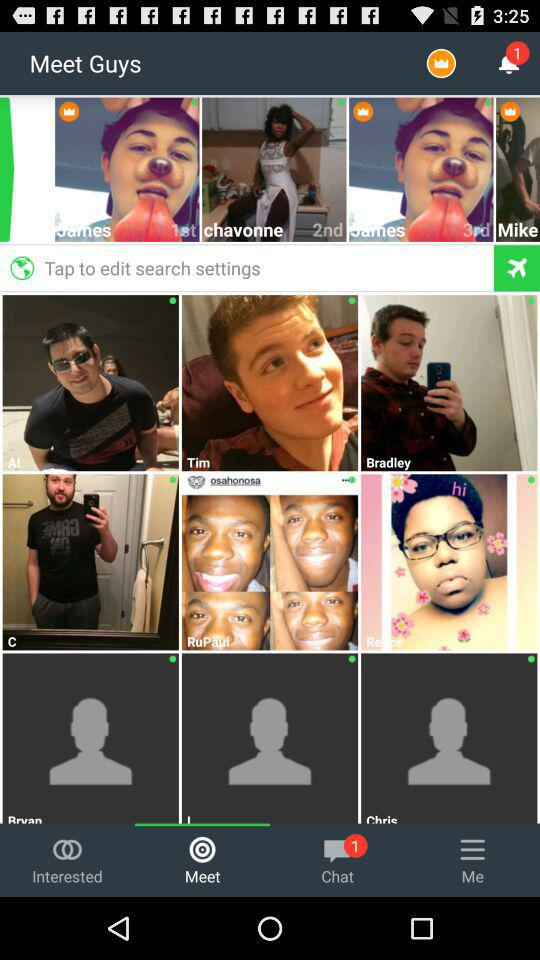Are there any unread chats?
When the provided information is insufficient, respond with <no answer>. <no answer> 